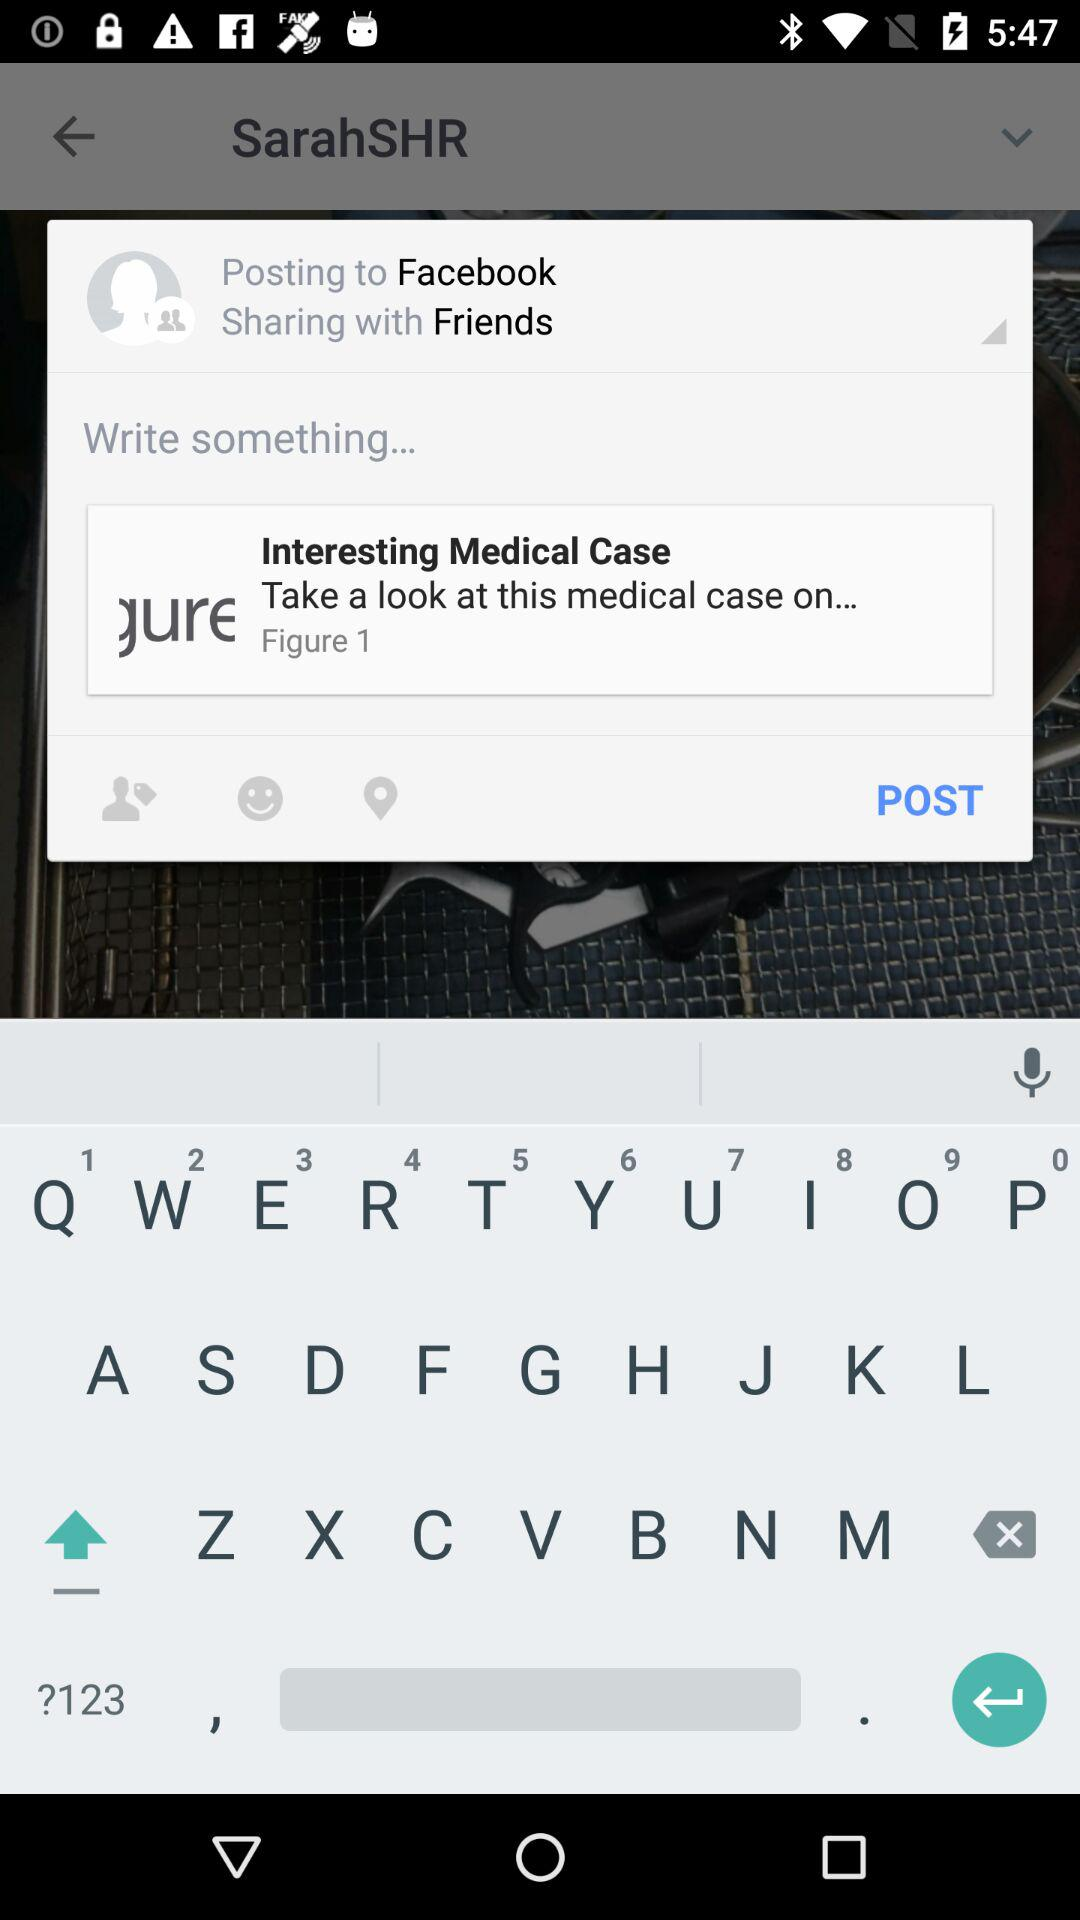What is the app name? The app name is "figure1". 